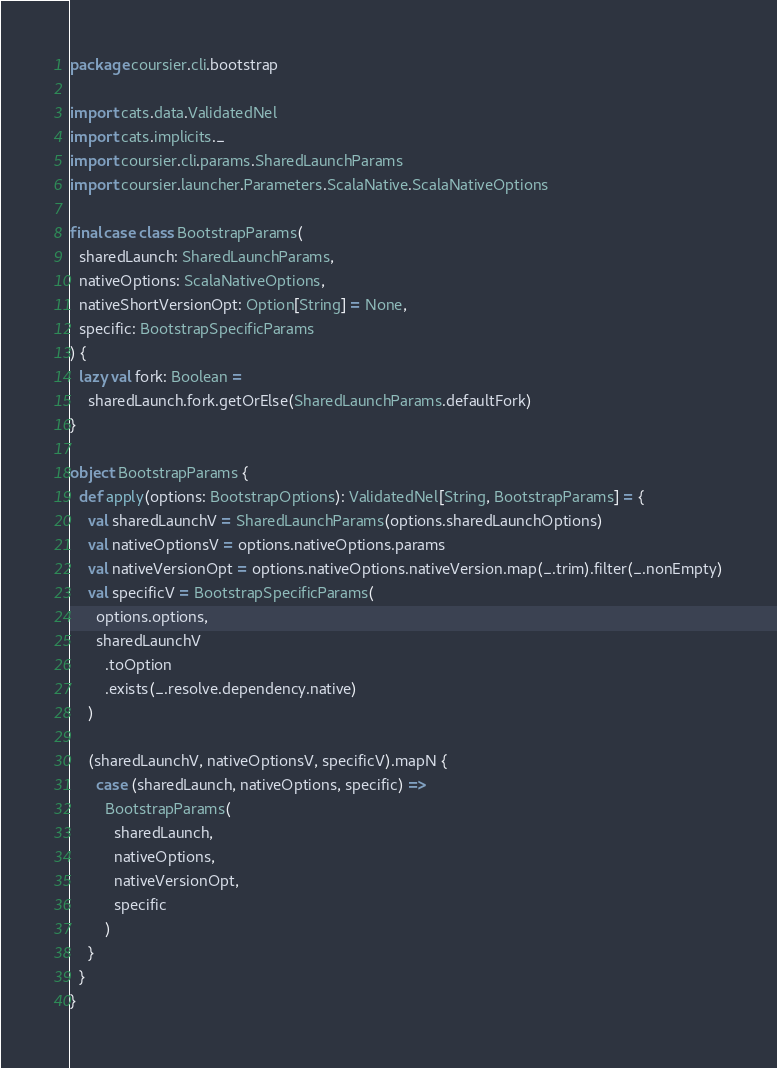Convert code to text. <code><loc_0><loc_0><loc_500><loc_500><_Scala_>package coursier.cli.bootstrap

import cats.data.ValidatedNel
import cats.implicits._
import coursier.cli.params.SharedLaunchParams
import coursier.launcher.Parameters.ScalaNative.ScalaNativeOptions

final case class BootstrapParams(
  sharedLaunch: SharedLaunchParams,
  nativeOptions: ScalaNativeOptions,
  nativeShortVersionOpt: Option[String] = None,
  specific: BootstrapSpecificParams
) {
  lazy val fork: Boolean =
    sharedLaunch.fork.getOrElse(SharedLaunchParams.defaultFork)
}

object BootstrapParams {
  def apply(options: BootstrapOptions): ValidatedNel[String, BootstrapParams] = {
    val sharedLaunchV = SharedLaunchParams(options.sharedLaunchOptions)
    val nativeOptionsV = options.nativeOptions.params
    val nativeVersionOpt = options.nativeOptions.nativeVersion.map(_.trim).filter(_.nonEmpty)
    val specificV = BootstrapSpecificParams(
      options.options,
      sharedLaunchV
        .toOption
        .exists(_.resolve.dependency.native)
    )

    (sharedLaunchV, nativeOptionsV, specificV).mapN {
      case (sharedLaunch, nativeOptions, specific) =>
        BootstrapParams(
          sharedLaunch,
          nativeOptions,
          nativeVersionOpt,
          specific
        )
    }
  }
}
</code> 